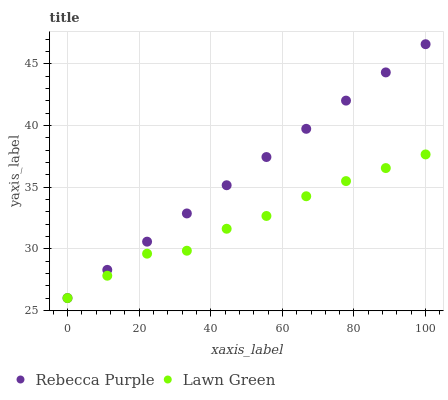Does Lawn Green have the minimum area under the curve?
Answer yes or no. Yes. Does Rebecca Purple have the maximum area under the curve?
Answer yes or no. Yes. Does Rebecca Purple have the minimum area under the curve?
Answer yes or no. No. Is Rebecca Purple the smoothest?
Answer yes or no. Yes. Is Lawn Green the roughest?
Answer yes or no. Yes. Is Rebecca Purple the roughest?
Answer yes or no. No. Does Lawn Green have the lowest value?
Answer yes or no. Yes. Does Rebecca Purple have the highest value?
Answer yes or no. Yes. Does Lawn Green intersect Rebecca Purple?
Answer yes or no. Yes. Is Lawn Green less than Rebecca Purple?
Answer yes or no. No. Is Lawn Green greater than Rebecca Purple?
Answer yes or no. No. 